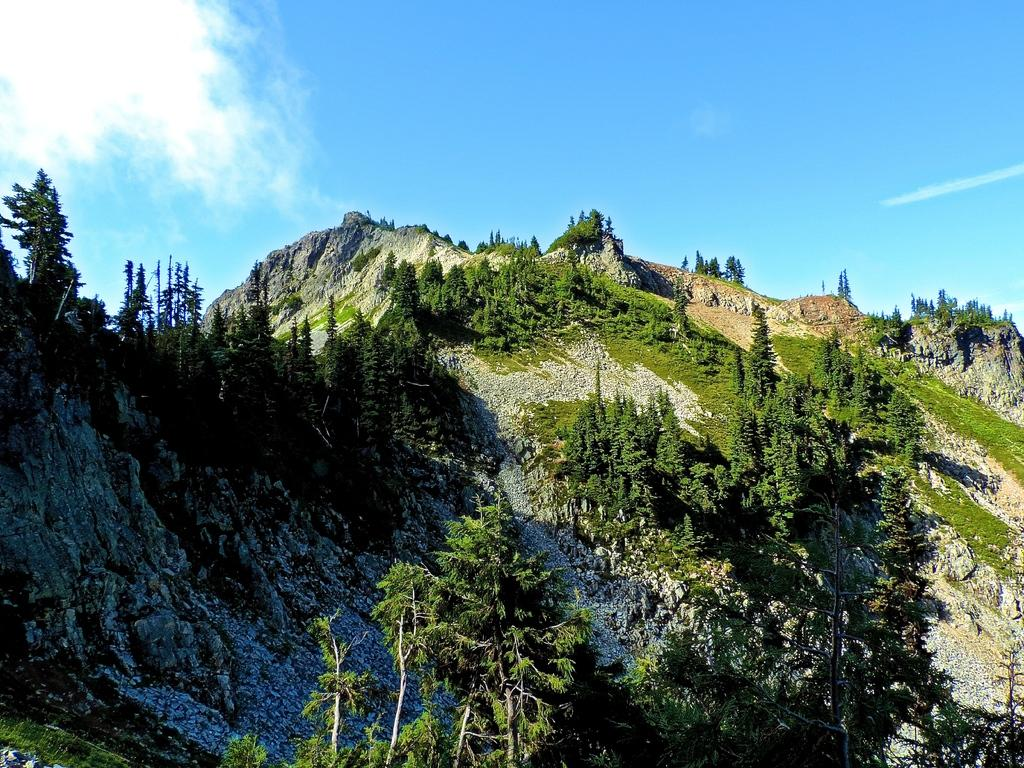What type of vegetation can be seen in the image? There are trees in the image. What type of geographical feature is present in the image? There are hills in the image. What is visible in the background of the image? The sky is visible in the background of the image. Can you tell me about the history of the boat in the image? There is no boat present in the image, so it is not possible to discuss its history. 